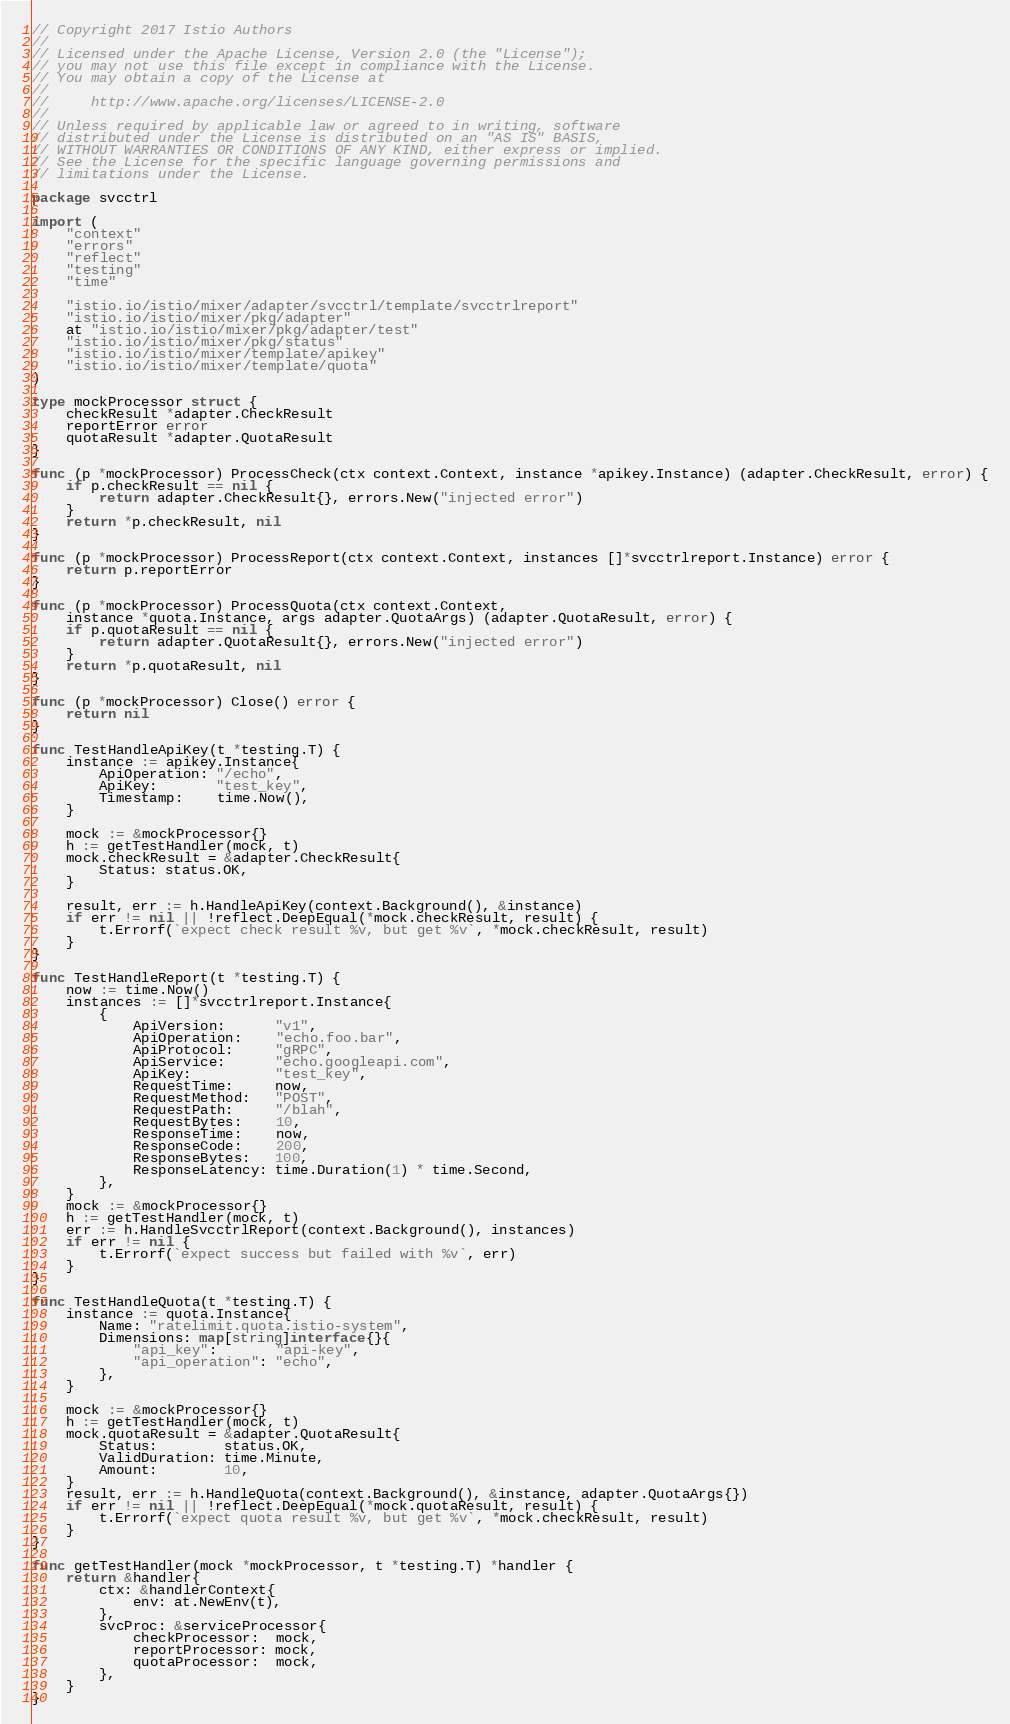Convert code to text. <code><loc_0><loc_0><loc_500><loc_500><_Go_>// Copyright 2017 Istio Authors
//
// Licensed under the Apache License, Version 2.0 (the "License");
// you may not use this file except in compliance with the License.
// You may obtain a copy of the License at
//
//     http://www.apache.org/licenses/LICENSE-2.0
//
// Unless required by applicable law or agreed to in writing, software
// distributed under the License is distributed on an "AS IS" BASIS,
// WITHOUT WARRANTIES OR CONDITIONS OF ANY KIND, either express or implied.
// See the License for the specific language governing permissions and
// limitations under the License.

package svcctrl

import (
	"context"
	"errors"
	"reflect"
	"testing"
	"time"

	"istio.io/istio/mixer/adapter/svcctrl/template/svcctrlreport"
	"istio.io/istio/mixer/pkg/adapter"
	at "istio.io/istio/mixer/pkg/adapter/test"
	"istio.io/istio/mixer/pkg/status"
	"istio.io/istio/mixer/template/apikey"
	"istio.io/istio/mixer/template/quota"
)

type mockProcessor struct {
	checkResult *adapter.CheckResult
	reportError error
	quotaResult *adapter.QuotaResult
}

func (p *mockProcessor) ProcessCheck(ctx context.Context, instance *apikey.Instance) (adapter.CheckResult, error) {
	if p.checkResult == nil {
		return adapter.CheckResult{}, errors.New("injected error")
	}
	return *p.checkResult, nil
}

func (p *mockProcessor) ProcessReport(ctx context.Context, instances []*svcctrlreport.Instance) error {
	return p.reportError
}

func (p *mockProcessor) ProcessQuota(ctx context.Context,
	instance *quota.Instance, args adapter.QuotaArgs) (adapter.QuotaResult, error) {
	if p.quotaResult == nil {
		return adapter.QuotaResult{}, errors.New("injected error")
	}
	return *p.quotaResult, nil
}

func (p *mockProcessor) Close() error {
	return nil
}

func TestHandleApiKey(t *testing.T) {
	instance := apikey.Instance{
		ApiOperation: "/echo",
		ApiKey:       "test_key",
		Timestamp:    time.Now(),
	}

	mock := &mockProcessor{}
	h := getTestHandler(mock, t)
	mock.checkResult = &adapter.CheckResult{
		Status: status.OK,
	}

	result, err := h.HandleApiKey(context.Background(), &instance)
	if err != nil || !reflect.DeepEqual(*mock.checkResult, result) {
		t.Errorf(`expect check result %v, but get %v`, *mock.checkResult, result)
	}
}

func TestHandleReport(t *testing.T) {
	now := time.Now()
	instances := []*svcctrlreport.Instance{
		{
			ApiVersion:      "v1",
			ApiOperation:    "echo.foo.bar",
			ApiProtocol:     "gRPC",
			ApiService:      "echo.googleapi.com",
			ApiKey:          "test_key",
			RequestTime:     now,
			RequestMethod:   "POST",
			RequestPath:     "/blah",
			RequestBytes:    10,
			ResponseTime:    now,
			ResponseCode:    200,
			ResponseBytes:   100,
			ResponseLatency: time.Duration(1) * time.Second,
		},
	}
	mock := &mockProcessor{}
	h := getTestHandler(mock, t)
	err := h.HandleSvcctrlReport(context.Background(), instances)
	if err != nil {
		t.Errorf(`expect success but failed with %v`, err)
	}
}

func TestHandleQuota(t *testing.T) {
	instance := quota.Instance{
		Name: "ratelimit.quota.istio-system",
		Dimensions: map[string]interface{}{
			"api_key":       "api-key",
			"api_operation": "echo",
		},
	}

	mock := &mockProcessor{}
	h := getTestHandler(mock, t)
	mock.quotaResult = &adapter.QuotaResult{
		Status:        status.OK,
		ValidDuration: time.Minute,
		Amount:        10,
	}
	result, err := h.HandleQuota(context.Background(), &instance, adapter.QuotaArgs{})
	if err != nil || !reflect.DeepEqual(*mock.quotaResult, result) {
		t.Errorf(`expect quota result %v, but get %v`, *mock.checkResult, result)
	}
}

func getTestHandler(mock *mockProcessor, t *testing.T) *handler {
	return &handler{
		ctx: &handlerContext{
			env: at.NewEnv(t),
		},
		svcProc: &serviceProcessor{
			checkProcessor:  mock,
			reportProcessor: mock,
			quotaProcessor:  mock,
		},
	}
}
</code> 